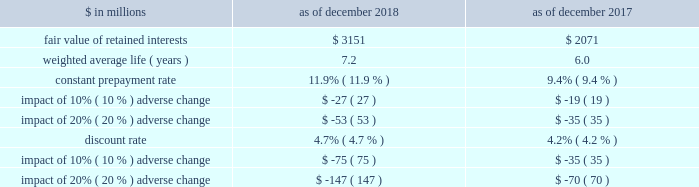The goldman sachs group , inc .
And subsidiaries notes to consolidated financial statements 2030 purchased interests represent senior and subordinated interests , purchased in connection with secondary market-making activities , in securitization entities in which the firm also holds retained interests .
2030 substantially all of the total outstanding principal amount and total retained interests relate to securitizations during 2014 and thereafter as of december 2018 , and relate to securitizations during 2012 and thereafter as of december 2017 .
2030 the fair value of retained interests was $ 3.28 billion as of december 2018 and $ 2.13 billion as of december 2017 .
In addition to the interests in the table above , the firm had other continuing involvement in the form of derivative transactions and commitments with certain nonconsolidated vies .
The carrying value of these derivatives and commitments was a net asset of $ 75 million as of december 2018 and $ 86 million as of december 2017 , and the notional amount of these derivatives and commitments was $ 1.09 billion as of december 2018 and $ 1.26 billion as of december 2017 .
The notional amounts of these derivatives and commitments are included in maximum exposure to loss in the nonconsolidated vie table in note 12 .
The table below presents information about the weighted average key economic assumptions used in measuring the fair value of mortgage-backed retained interests. .
In the table above : 2030 amounts do not reflect the benefit of other financial instruments that are held to mitigate risks inherent in these retained interests .
2030 changes in fair value based on an adverse variation in assumptions generally cannot be extrapolated because the relationship of the change in assumptions to the change in fair value is not usually linear .
2030 the impact of a change in a particular assumption is calculated independently of changes in any other assumption .
In practice , simultaneous changes in assumptions might magnify or counteract the sensitivities disclosed above .
2030 the constant prepayment rate is included only for positions for which it is a key assumption in the determination of fair value .
2030 the discount rate for retained interests that relate to u.s .
Government agency-issued collateralized mortgage obligations does not include any credit loss .
Expected credit loss assumptions are reflected in the discount rate for the remainder of retained interests .
The firm has other retained interests not reflected in the table above with a fair value of $ 133 million and a weighted average life of 4.2 years as of december 2018 , and a fair value of $ 56 million and a weighted average life of 4.5 years as of december 2017 .
Due to the nature and fair value of certain of these retained interests , the weighted average assumptions for constant prepayment and discount rates and the related sensitivity to adverse changes are not meaningful as of both december 2018 and december 2017 .
The firm 2019s maximum exposure to adverse changes in the value of these interests is the carrying value of $ 133 million as of december 2018 and $ 56 million as of december 2017 .
Note 12 .
Variable interest entities a variable interest in a vie is an investment ( e.g. , debt or equity ) or other interest ( e.g. , derivatives or loans and lending commitments ) that will absorb portions of the vie 2019s expected losses and/or receive portions of the vie 2019s expected residual returns .
The firm 2019s variable interests in vies include senior and subordinated debt ; loans and lending commitments ; limited and general partnership interests ; preferred and common equity ; derivatives that may include foreign currency , equity and/or credit risk ; guarantees ; and certain of the fees the firm receives from investment funds .
Certain interest rate , foreign currency and credit derivatives the firm enters into with vies are not variable interests because they create , rather than absorb , risk .
Vies generally finance the purchase of assets by issuing debt and equity securities that are either collateralized by or indexed to the assets held by the vie .
The debt and equity securities issued by a vie may include tranches of varying levels of subordination .
The firm 2019s involvement with vies includes securitization of financial assets , as described in note 11 , and investments in and loans to other types of vies , as described below .
See note 11 for further information about securitization activities , including the definition of beneficial interests .
See note 3 for the firm 2019s consolidation policies , including the definition of a vie .
Goldman sachs 2018 form 10-k 149 .
What is the growth rate in the fair value of retained interests in 2018 compare to 2017? 
Computations: ((3.28 - 2.13) / 2.13)
Answer: 0.53991. 